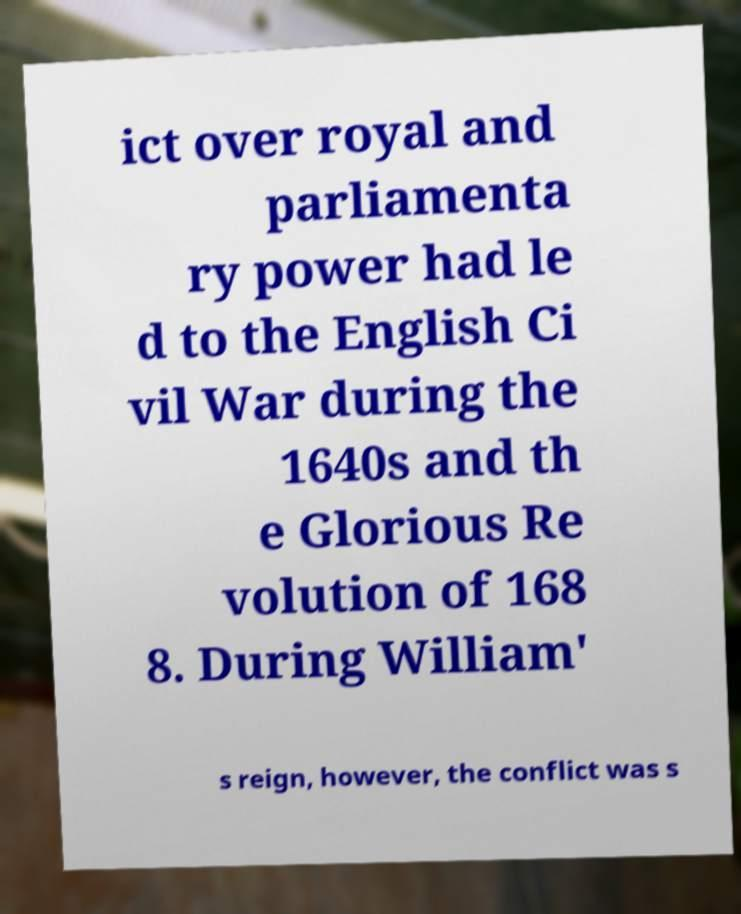Can you accurately transcribe the text from the provided image for me? ict over royal and parliamenta ry power had le d to the English Ci vil War during the 1640s and th e Glorious Re volution of 168 8. During William' s reign, however, the conflict was s 